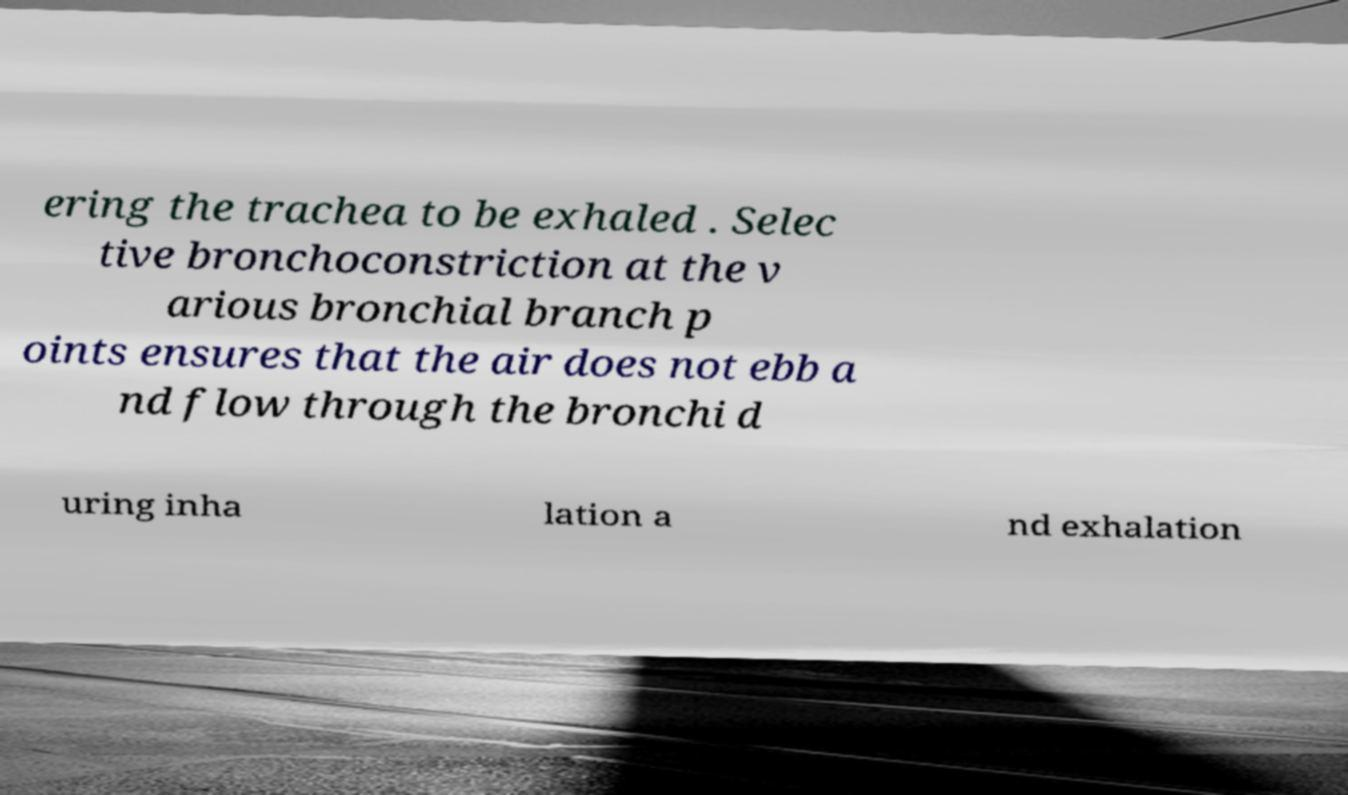Can you read and provide the text displayed in the image?This photo seems to have some interesting text. Can you extract and type it out for me? ering the trachea to be exhaled . Selec tive bronchoconstriction at the v arious bronchial branch p oints ensures that the air does not ebb a nd flow through the bronchi d uring inha lation a nd exhalation 